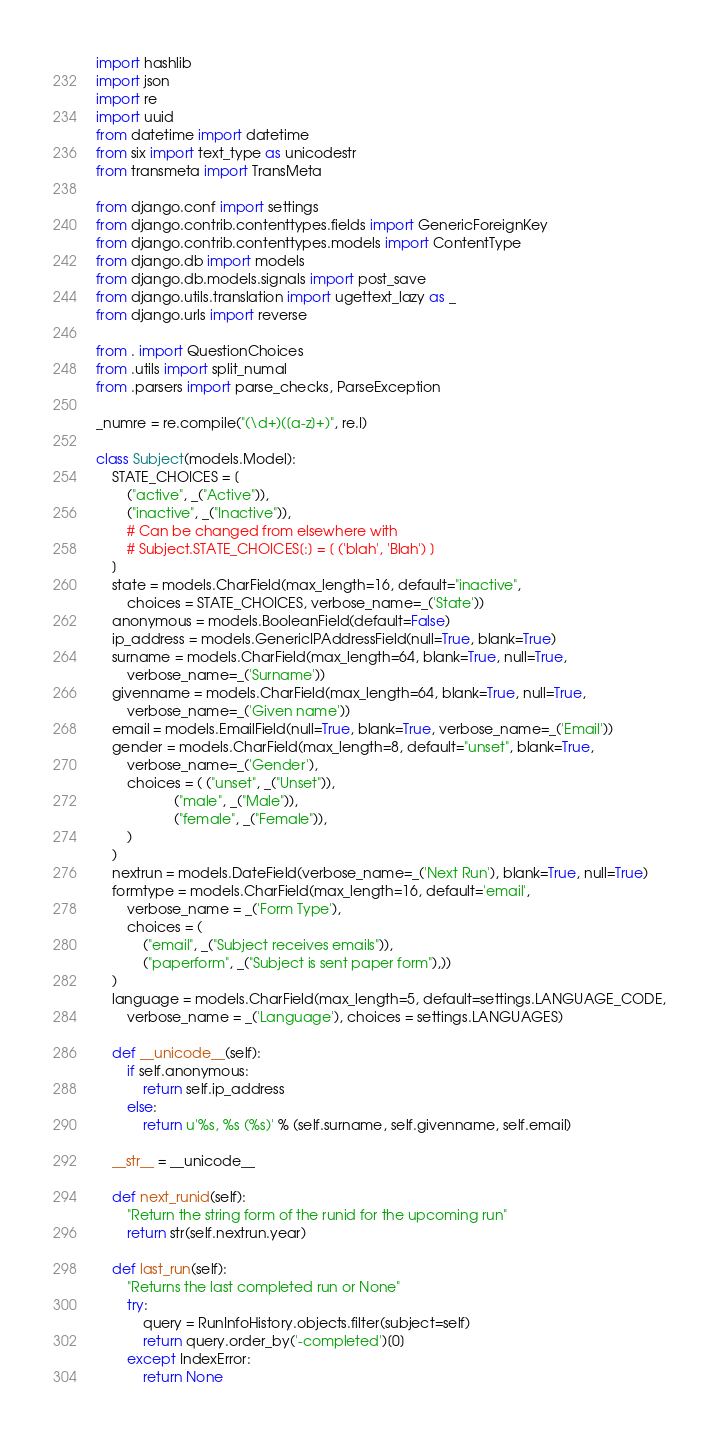Convert code to text. <code><loc_0><loc_0><loc_500><loc_500><_Python_>import hashlib
import json
import re
import uuid
from datetime import datetime
from six import text_type as unicodestr
from transmeta import TransMeta

from django.conf import settings
from django.contrib.contenttypes.fields import GenericForeignKey
from django.contrib.contenttypes.models import ContentType
from django.db import models
from django.db.models.signals import post_save
from django.utils.translation import ugettext_lazy as _
from django.urls import reverse

from . import QuestionChoices
from .utils import split_numal
from .parsers import parse_checks, ParseException

_numre = re.compile("(\d+)([a-z]+)", re.I)

class Subject(models.Model):
    STATE_CHOICES = [
        ("active", _("Active")),
        ("inactive", _("Inactive")),
        # Can be changed from elsewhere with
        # Subject.STATE_CHOICES[:] = [ ('blah', 'Blah') ]
    ]
    state = models.CharField(max_length=16, default="inactive",
        choices = STATE_CHOICES, verbose_name=_('State'))
    anonymous = models.BooleanField(default=False)
    ip_address = models.GenericIPAddressField(null=True, blank=True)
    surname = models.CharField(max_length=64, blank=True, null=True,
        verbose_name=_('Surname'))
    givenname = models.CharField(max_length=64, blank=True, null=True,
        verbose_name=_('Given name'))
    email = models.EmailField(null=True, blank=True, verbose_name=_('Email'))
    gender = models.CharField(max_length=8, default="unset", blank=True,
        verbose_name=_('Gender'),
        choices = ( ("unset", _("Unset")),
                    ("male", _("Male")),
                    ("female", _("Female")),
        )
    )
    nextrun = models.DateField(verbose_name=_('Next Run'), blank=True, null=True)
    formtype = models.CharField(max_length=16, default='email',
        verbose_name = _('Form Type'),
        choices = (
            ("email", _("Subject receives emails")),
            ("paperform", _("Subject is sent paper form"),))
    )
    language = models.CharField(max_length=5, default=settings.LANGUAGE_CODE,
        verbose_name = _('Language'), choices = settings.LANGUAGES)

    def __unicode__(self):
        if self.anonymous:
            return self.ip_address
        else:
            return u'%s, %s (%s)' % (self.surname, self.givenname, self.email)

    __str__ = __unicode__

    def next_runid(self):
        "Return the string form of the runid for the upcoming run"
        return str(self.nextrun.year)

    def last_run(self):
        "Returns the last completed run or None"
        try:
            query = RunInfoHistory.objects.filter(subject=self)
            return query.order_by('-completed')[0]
        except IndexError:
            return None
</code> 